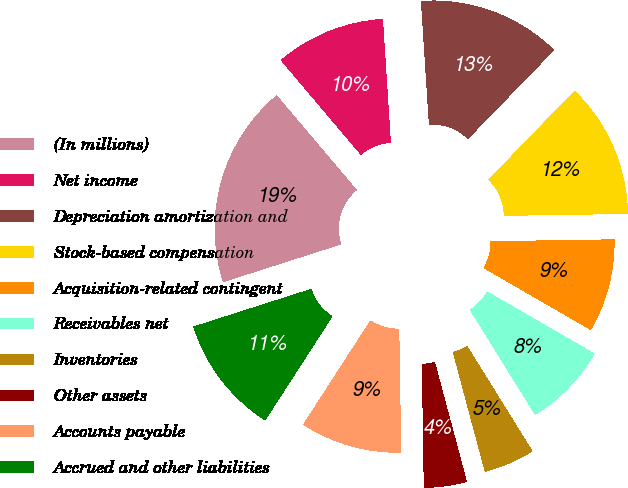Convert chart. <chart><loc_0><loc_0><loc_500><loc_500><pie_chart><fcel>(In millions)<fcel>Net income<fcel>Depreciation amortization and<fcel>Stock-based compensation<fcel>Acquisition-related contingent<fcel>Receivables net<fcel>Inventories<fcel>Other assets<fcel>Accounts payable<fcel>Accrued and other liabilities<nl><fcel>18.75%<fcel>10.16%<fcel>13.28%<fcel>12.5%<fcel>8.59%<fcel>7.81%<fcel>4.69%<fcel>3.91%<fcel>9.38%<fcel>10.94%<nl></chart> 